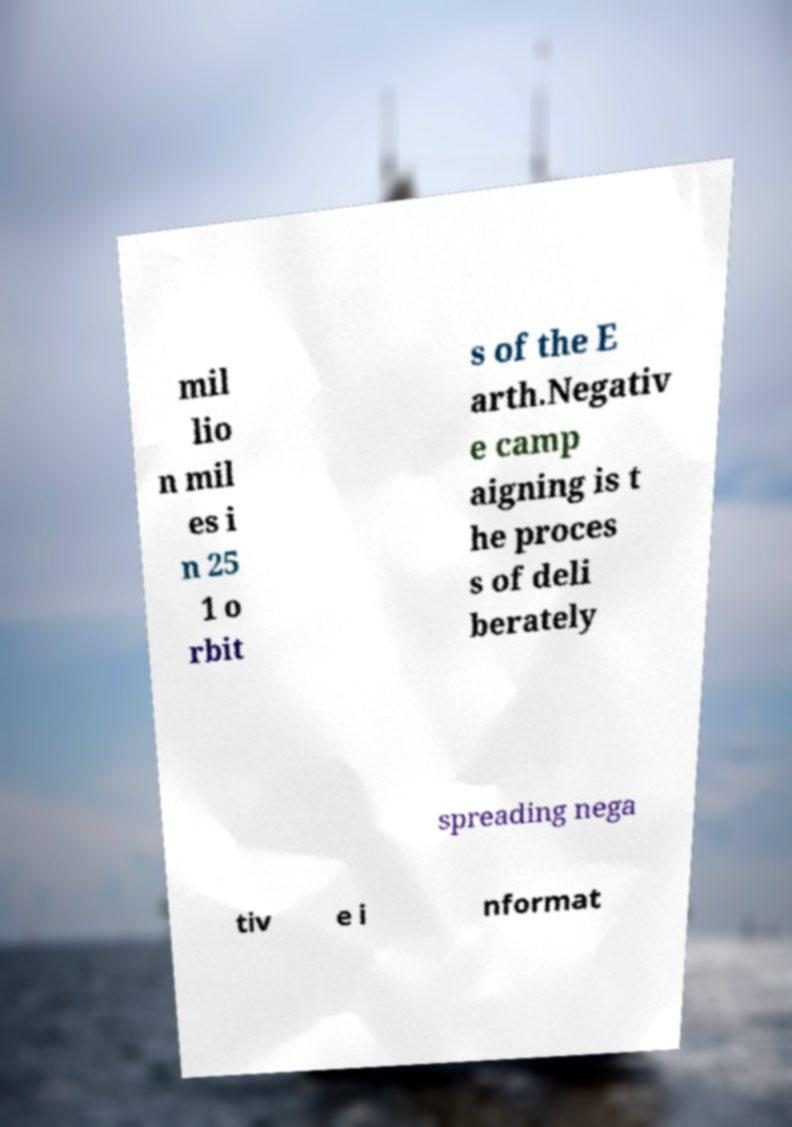There's text embedded in this image that I need extracted. Can you transcribe it verbatim? mil lio n mil es i n 25 1 o rbit s of the E arth.Negativ e camp aigning is t he proces s of deli berately spreading nega tiv e i nformat 